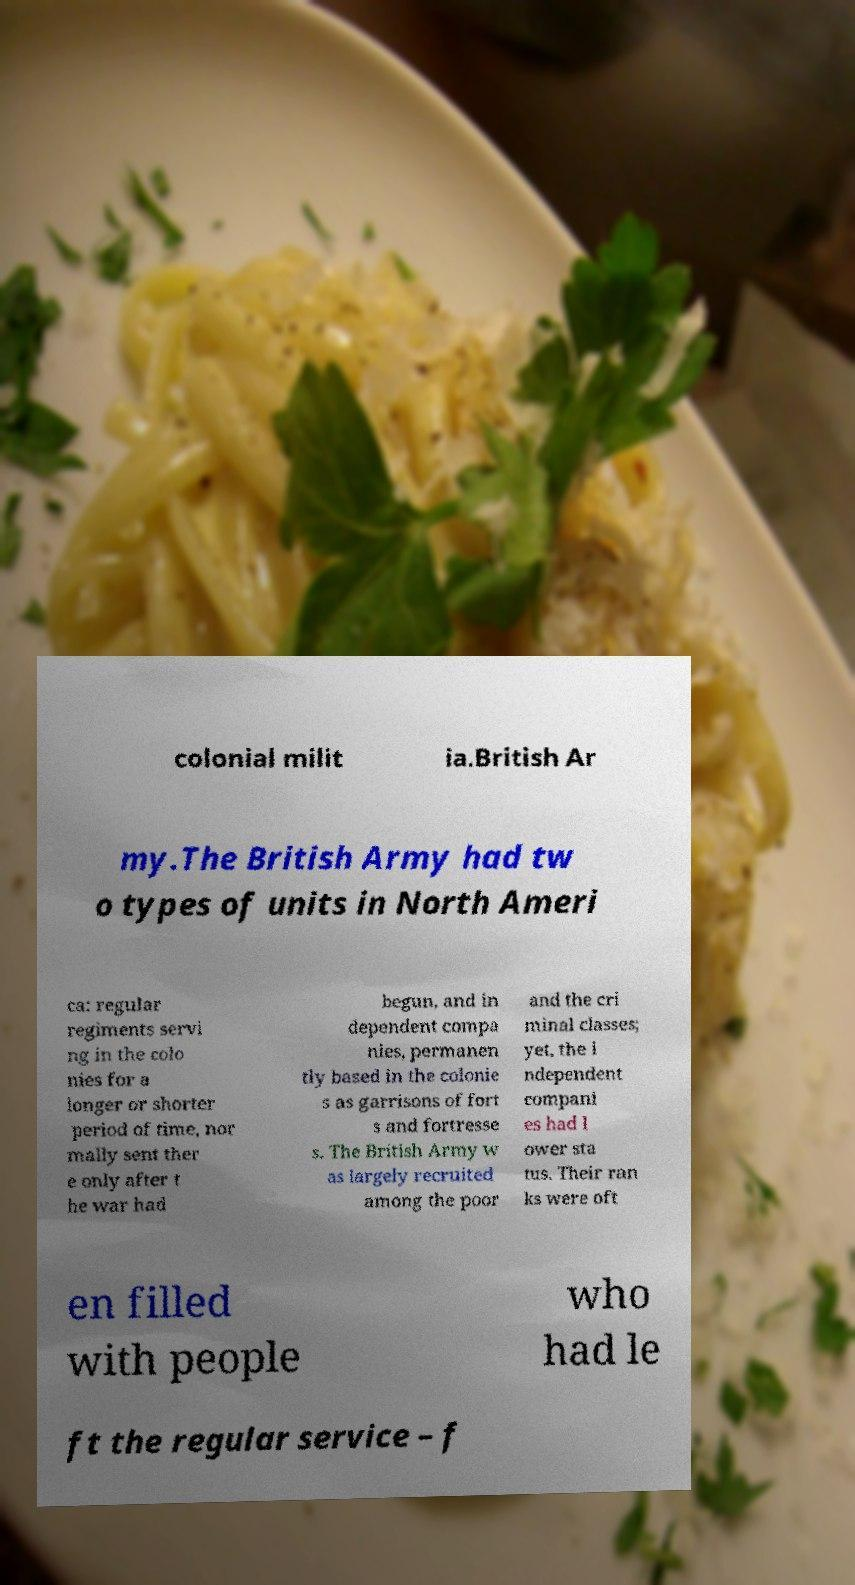Can you read and provide the text displayed in the image?This photo seems to have some interesting text. Can you extract and type it out for me? colonial milit ia.British Ar my.The British Army had tw o types of units in North Ameri ca: regular regiments servi ng in the colo nies for a longer or shorter period of time, nor mally sent ther e only after t he war had begun, and in dependent compa nies, permanen tly based in the colonie s as garrisons of fort s and fortresse s. The British Army w as largely recruited among the poor and the cri minal classes; yet, the i ndependent compani es had l ower sta tus. Their ran ks were oft en filled with people who had le ft the regular service – f 